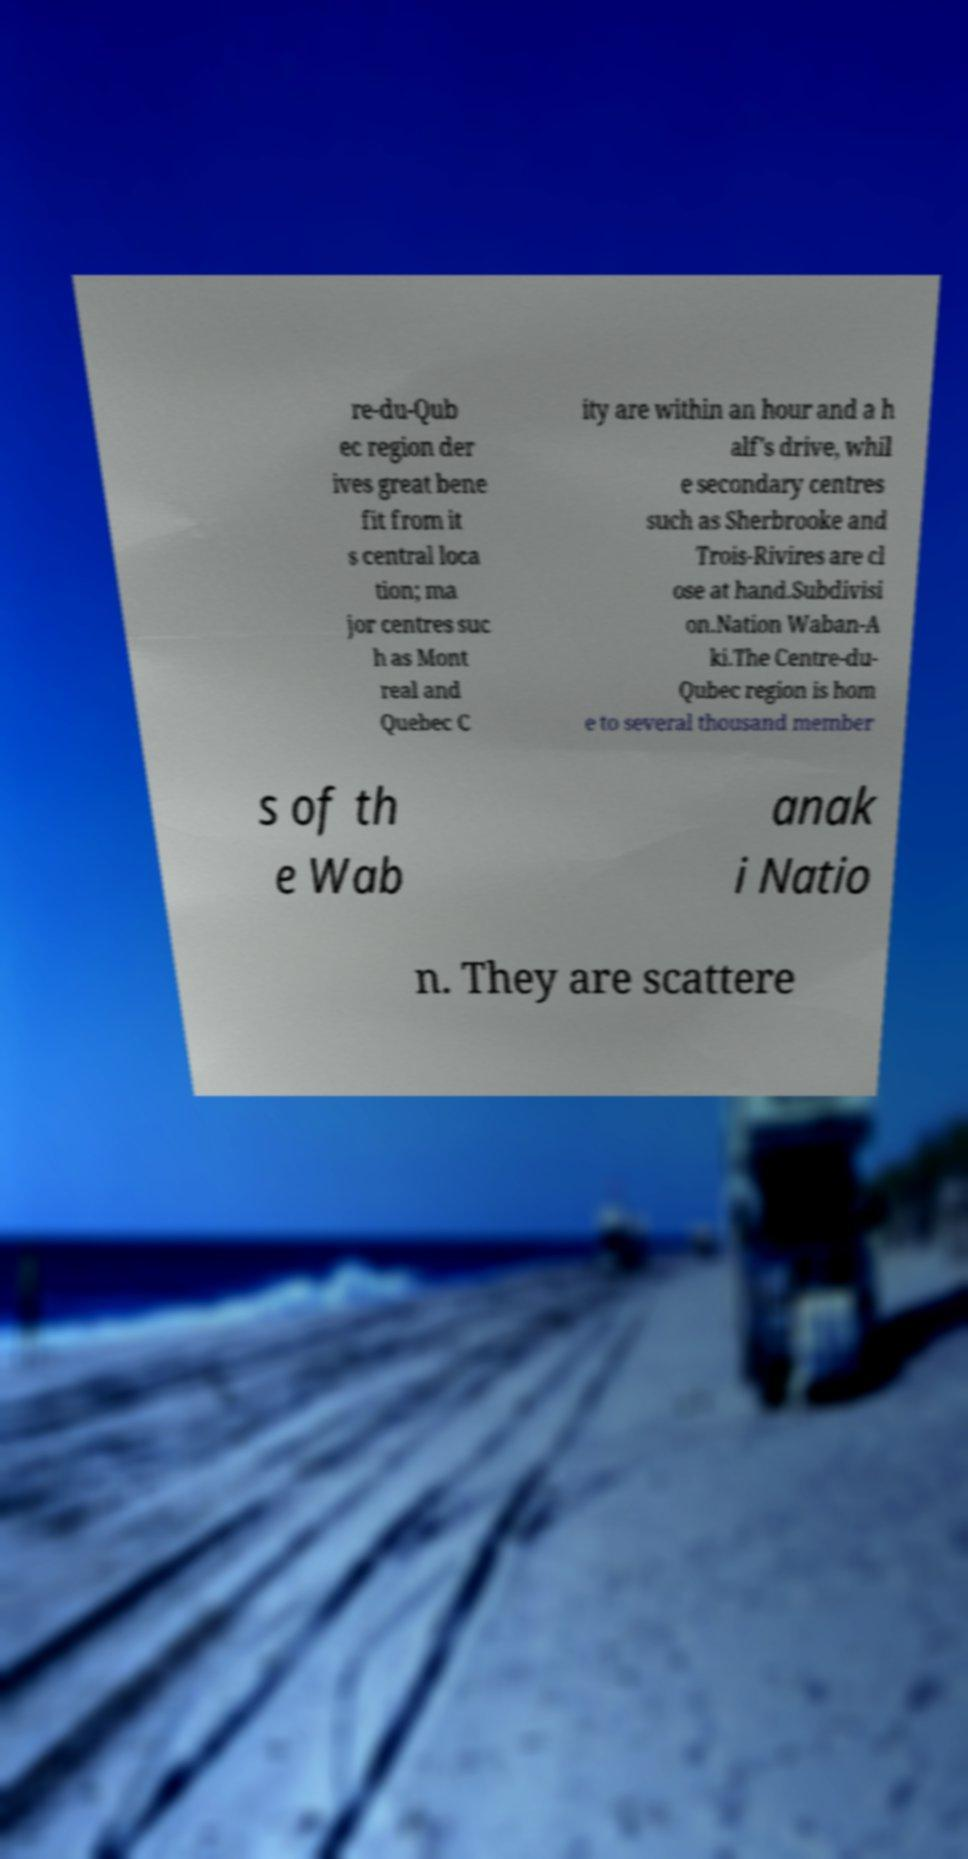Can you read and provide the text displayed in the image?This photo seems to have some interesting text. Can you extract and type it out for me? re-du-Qub ec region der ives great bene fit from it s central loca tion; ma jor centres suc h as Mont real and Quebec C ity are within an hour and a h alf's drive, whil e secondary centres such as Sherbrooke and Trois-Rivires are cl ose at hand.Subdivisi on.Nation Waban-A ki.The Centre-du- Qubec region is hom e to several thousand member s of th e Wab anak i Natio n. They are scattere 